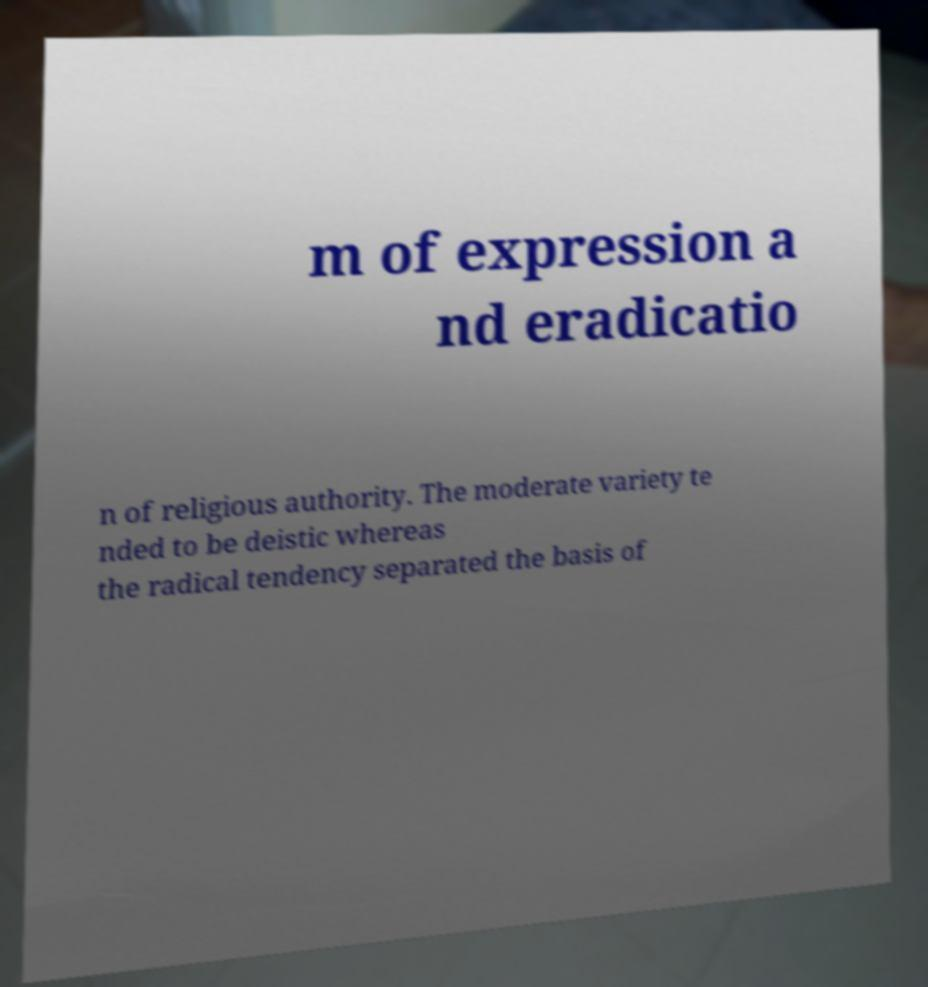Could you extract and type out the text from this image? m of expression a nd eradicatio n of religious authority. The moderate variety te nded to be deistic whereas the radical tendency separated the basis of 